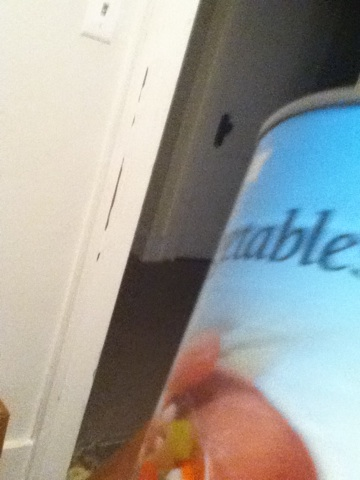Can you tell me more details about this can? This can appears to be a commercially packed can of mixed vegetables. The label suggests it contains a mixture of different vegetables, usually preserved in water or brine. Such cans are convenient for quick meals and can be used in various recipes like soups, stews, and casseroles. What can you make with the contents of this can? With a can of mixed vegetables, you can make a variety of dishes such as a hearty vegetable soup, a mixed vegetable casserole, or even a quick vegetable stir-fry. You can also use them as a convenient addition to pasta dishes, rice bowls, or pot pies. 